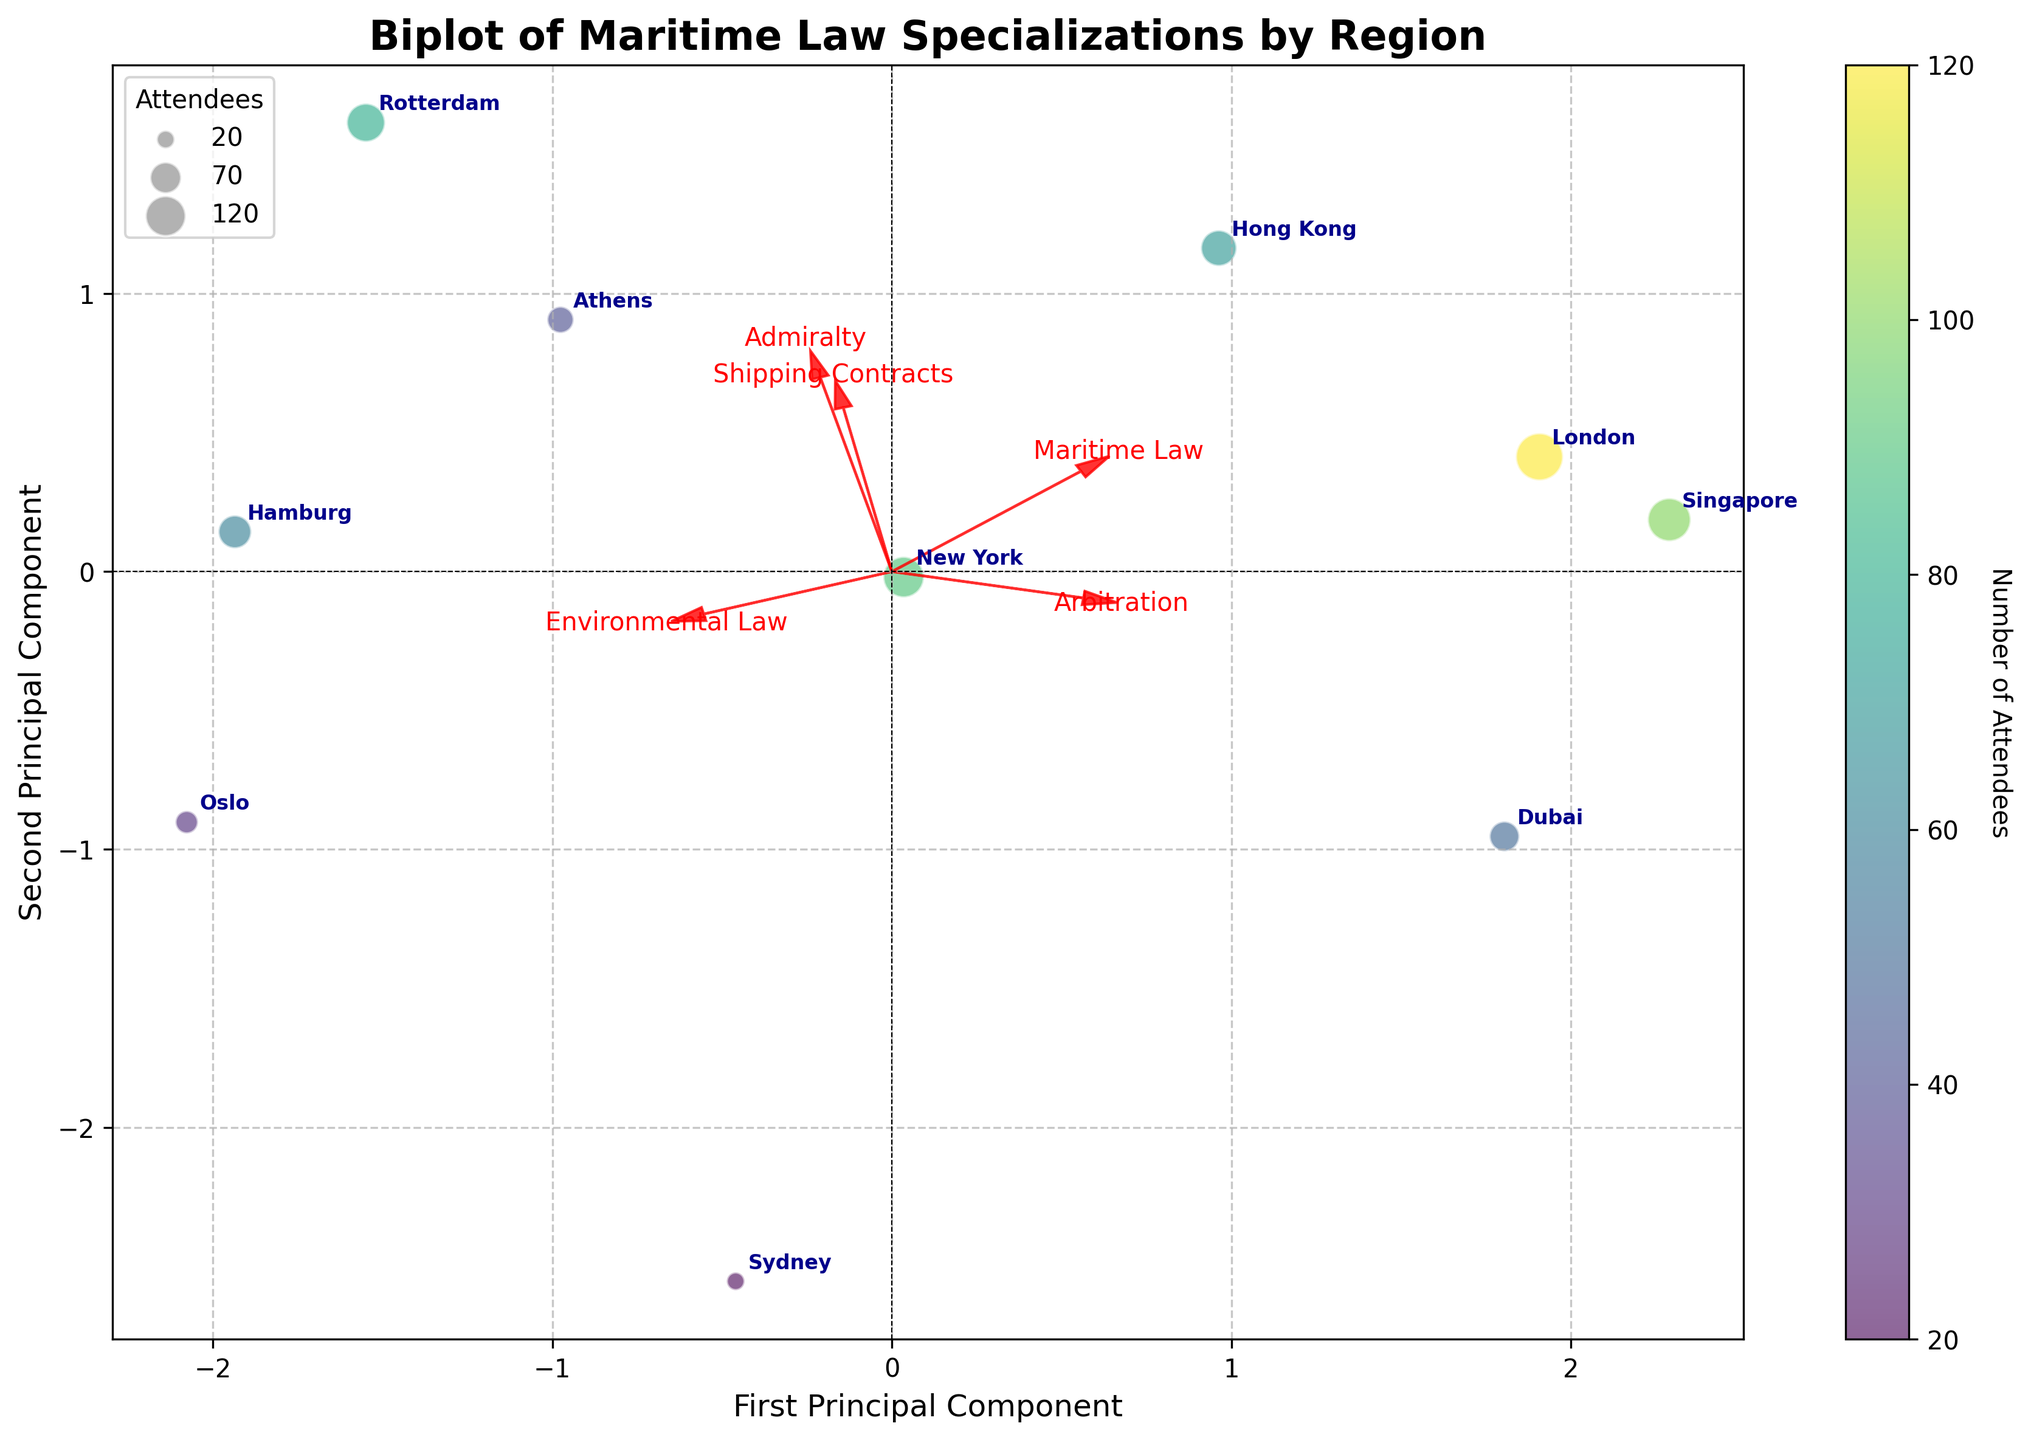What does the red arrow pointing towards the top right represent? The red arrows in a biplot represent the directions and strengths of the maritime law specializations on the principal components. The arrow pointing towards the top right indicates a maritime law specialization that has a strong positive relationship with both principal components. Looking at the figure, this arrow corresponds to 'Arbitration'.
Answer: Arbitration Which region has the highest number of attendees? Regions are annotated on the plot, and the color code also indicates the number of attendees. The largest and darkest circle on the biplot represents London, indicating that London has the highest number of attendees.
Answer: London Which maritime law specialization is most closely associated with the first principal component? The principal components are represented by the axes on the biplot. The specialization with the arrow aligned most closely with the first principal component (horizontal axis) is 'Maritime Law'.
Answer: Maritime Law Compare the positions of London and New York in the biplot. Which specialization do they both show a positive association with? In the biplot, both London and New York are positioned towards the right side, which means they are positively associated with specializations pointing in this direction. The arrow for 'Maritime Law' is pointing to the right, indicating that both London and New York show a positive association with 'Maritime Law'.
Answer: Maritime Law Which region shows a strong association with 'Environmental Law'? We need to look for a region that lies in the direction of the 'Environmental Law' arrow. Hamburg is positioned in the direction where 'Environmental Law' is pointing, suggesting a strong association with this specialization.
Answer: Hamburg Is there any specialization that Oslo shows a strong positive association with? Oslo is located towards the bottom-right of the plot, which indicates its associations with the specializations in those directions. The arrow for 'Environmental Law' points towards Oslo, indicating a strong positive association.
Answer: Environmental Law How many regions have at least a partial positive association with 'Shipping Contracts'? Regions positively associated with 'Shipping Contracts' will be positioned in the direction of the arrow for this specialization. The regions located in this direction include Hong Kong, Rotterdam, Hamburg, and Oslo. There are four regions in total.
Answer: 4 Which region has the smallest number of attendees, and which specialization is it closest to? The smallest circle on the biplot represents Sydney, which has the smallest number of attendees. Sydney is positioned closest to the specialization 'Environmental Law'.
Answer: Sydney, Environmental Law Compare the directions of the arrows for 'Admiralty' and 'Arbitration'. What does it imply about their relationship? The arrows for 'Admiralty' and 'Arbitration' point in similar directions, though not exactly the same. They both have positive loadings on the second principal component, implying that 'Admiralty' and 'Arbitration' are positively correlated.
Answer: They are positively correlated 